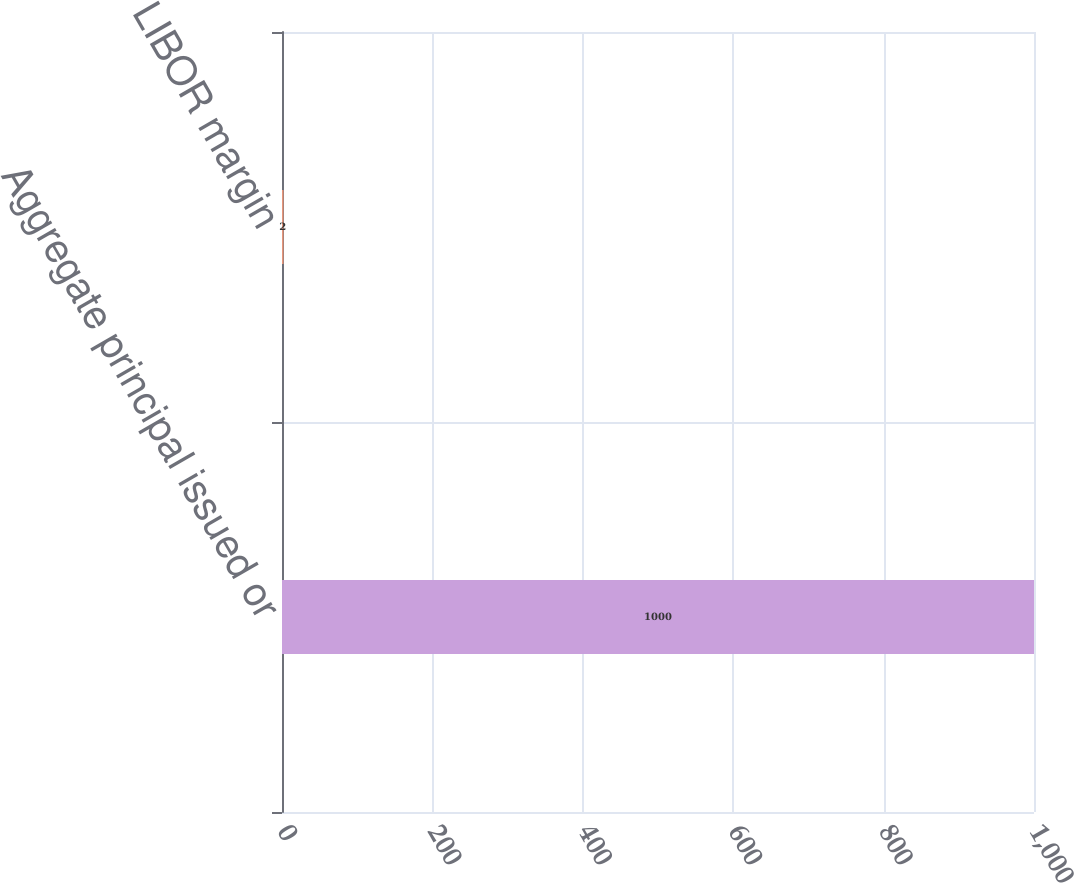Convert chart to OTSL. <chart><loc_0><loc_0><loc_500><loc_500><bar_chart><fcel>Aggregate principal issued or<fcel>LIBOR margin<nl><fcel>1000<fcel>2<nl></chart> 